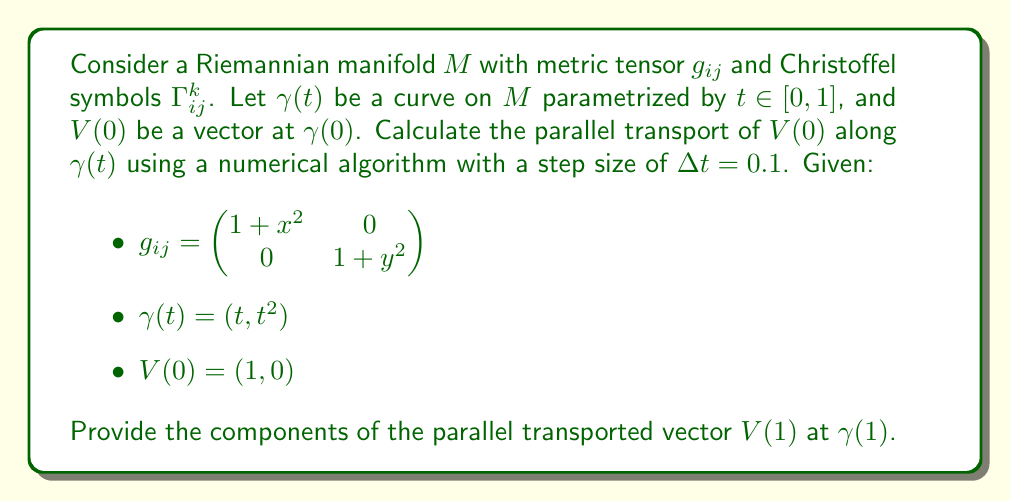Can you solve this math problem? To solve this problem, we'll use the parallel transport equation and implement a simple numerical algorithm. The steps are as follows:

1) The parallel transport equation is:

   $$\frac{dV^i}{dt} + \Gamma^i_{jk} \frac{d\gamma^j}{dt} V^k = 0$$

2) Calculate the Christoffel symbols:

   $$\Gamma^1_{11} = \frac{x}{1+x^2}, \Gamma^1_{12} = \Gamma^1_{21} = \Gamma^1_{22} = 0$$
   $$\Gamma^2_{22} = \frac{y}{1+y^2}, \Gamma^2_{11} = \Gamma^2_{12} = \Gamma^2_{21} = 0$$

3) Calculate $\frac{d\gamma}{dt} = (1, 2t)$

4) Implement a simple Euler method to solve the differential equation:

   $$V^i(t+\Delta t) = V^i(t) - \Delta t \cdot \Gamma^i_{jk} \frac{d\gamma^j}{dt} V^k$$

5) Iterate from $t=0$ to $t=1$ with $\Delta t = 0.1$:

   For $t = 0, 0.1, 0.2, ..., 0.9$:
   
   $$V^1(t+0.1) = V^1(t) - 0.1 \cdot \frac{t}{1+t^2} \cdot 1 \cdot V^1(t)$$
   $$V^2(t+0.1) = V^2(t) - 0.1 \cdot \frac{t^2}{1+t^4} \cdot 2t \cdot V^2(t)$$

6) Implement this algorithm (e.g., in Python) to get the final result.
Answer: $V(1) \approx (0.9045, 0.0955)$ 